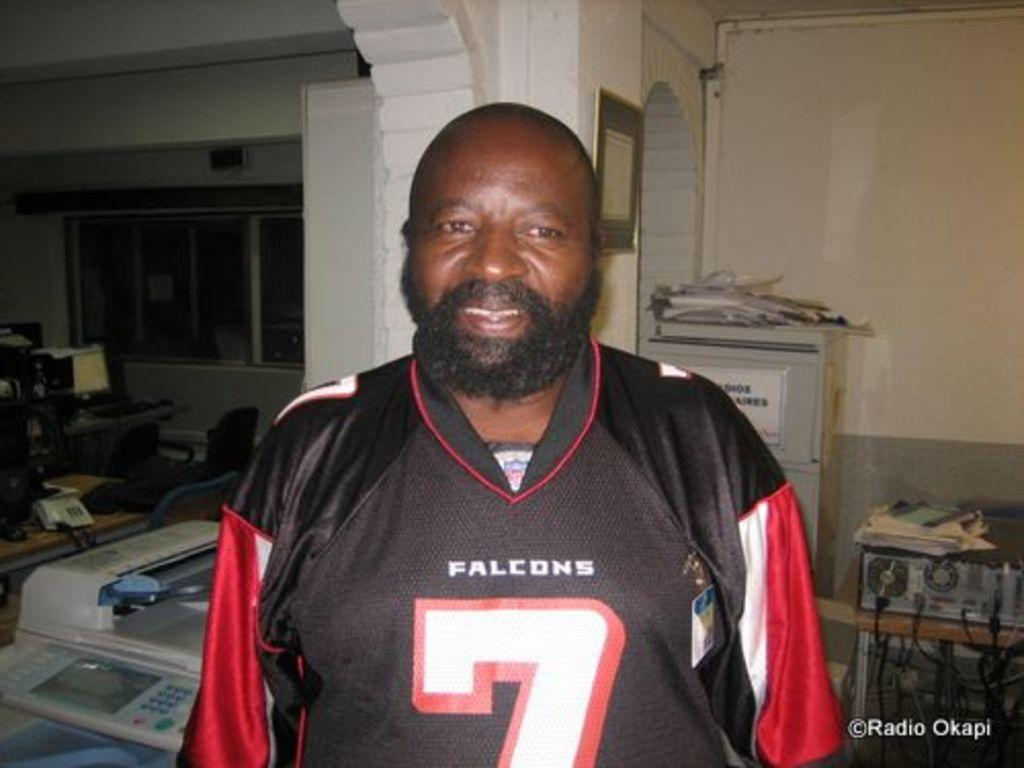<image>
Offer a succinct explanation of the picture presented. A man in an office is wearing a black Falcons jersey that has a 7 on it. 